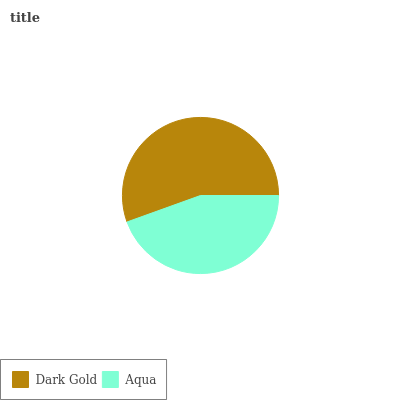Is Aqua the minimum?
Answer yes or no. Yes. Is Dark Gold the maximum?
Answer yes or no. Yes. Is Aqua the maximum?
Answer yes or no. No. Is Dark Gold greater than Aqua?
Answer yes or no. Yes. Is Aqua less than Dark Gold?
Answer yes or no. Yes. Is Aqua greater than Dark Gold?
Answer yes or no. No. Is Dark Gold less than Aqua?
Answer yes or no. No. Is Dark Gold the high median?
Answer yes or no. Yes. Is Aqua the low median?
Answer yes or no. Yes. Is Aqua the high median?
Answer yes or no. No. Is Dark Gold the low median?
Answer yes or no. No. 